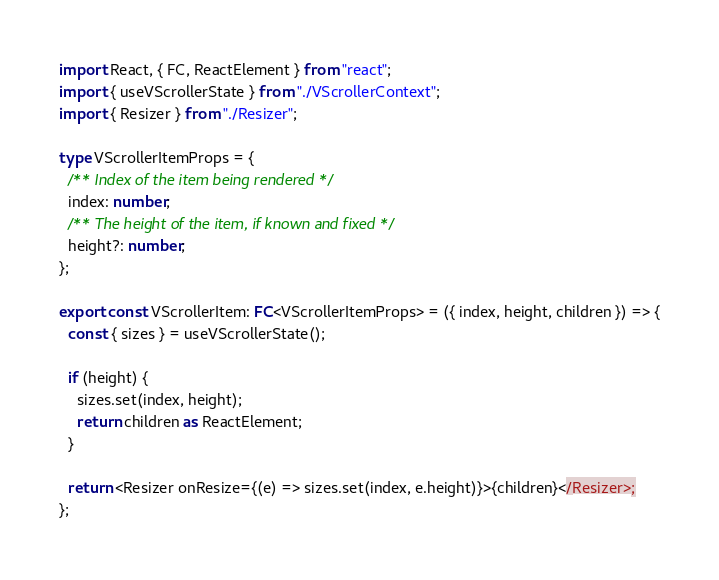<code> <loc_0><loc_0><loc_500><loc_500><_TypeScript_>import React, { FC, ReactElement } from "react";
import { useVScrollerState } from "./VScrollerContext";
import { Resizer } from "./Resizer";

type VScrollerItemProps = {
  /** Index of the item being rendered */
  index: number;
  /** The height of the item, if known and fixed */
  height?: number;
};

export const VScrollerItem: FC<VScrollerItemProps> = ({ index, height, children }) => {
  const { sizes } = useVScrollerState();

  if (height) {
    sizes.set(index, height);
    return children as ReactElement;
  }

  return <Resizer onResize={(e) => sizes.set(index, e.height)}>{children}</Resizer>;
};
</code> 